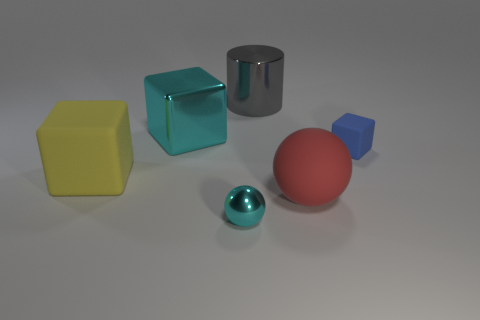What number of metal objects are the same color as the tiny metal sphere?
Provide a short and direct response. 1. There is a large shiny block; is it the same color as the metallic thing that is in front of the tiny blue matte thing?
Offer a terse response. Yes. How many objects are blue things or small objects behind the big yellow thing?
Give a very brief answer. 1. There is a cube right of the cyan metallic object in front of the yellow block; what size is it?
Make the answer very short. Small. Are there an equal number of large cyan blocks that are left of the large yellow matte cube and red rubber spheres that are left of the small blue rubber object?
Provide a short and direct response. No. Is there a red rubber object that is right of the cyan thing behind the blue rubber block?
Offer a very short reply. Yes. The other tiny thing that is the same material as the red object is what shape?
Your answer should be compact. Cube. Is there anything else that has the same color as the big rubber sphere?
Make the answer very short. No. There is a cyan thing that is behind the large rubber thing that is behind the big red thing; what is it made of?
Offer a very short reply. Metal. Are there any big yellow objects of the same shape as the blue rubber thing?
Make the answer very short. Yes. 